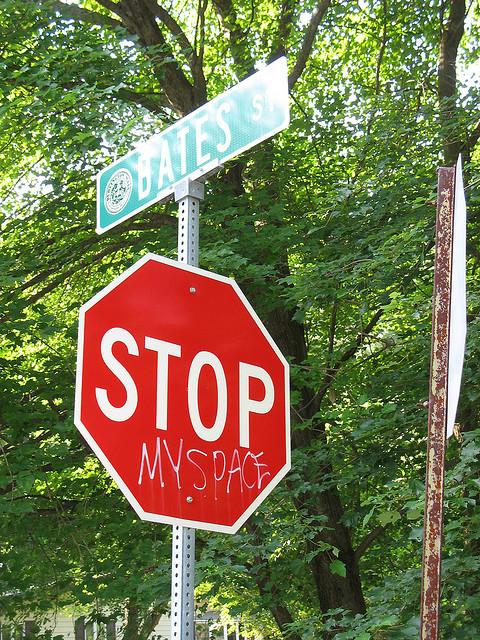Is there writing under the word stop?
Short answer required. Yes. Who wrote my space on the stop sign?
Keep it brief. Teenager. What color are the leaves?
Short answer required. Green. Why are there scratches on the sign?
Short answer required. Graffiti. 